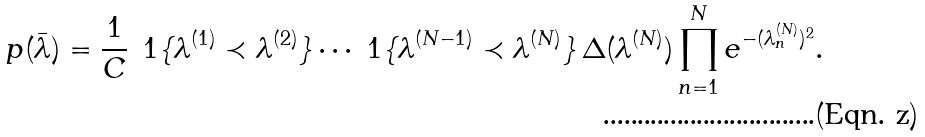<formula> <loc_0><loc_0><loc_500><loc_500>p ( \bar { \lambda } ) = \frac { 1 } { C } \, \ 1 \{ \lambda ^ { ( 1 ) } \prec \lambda ^ { ( 2 ) } \} \cdots \ 1 \{ \lambda ^ { ( N - 1 ) } \prec \lambda ^ { ( N ) } \} \, \Delta ( \lambda ^ { ( N ) } ) \prod _ { n = 1 } ^ { N } e ^ { - ( \lambda ^ { ( N ) } _ { n } ) ^ { 2 } } .</formula> 